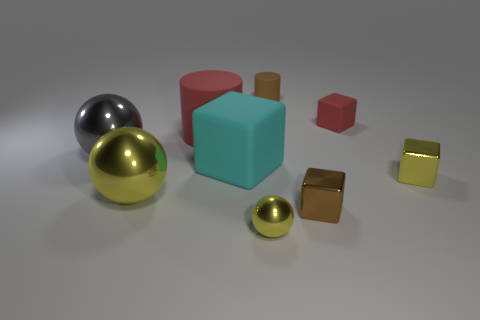The cylinder that is the same color as the small rubber block is what size?
Provide a short and direct response. Large. Is the color of the tiny rubber cube the same as the small cylinder?
Provide a short and direct response. No. What shape is the tiny brown metallic object?
Keep it short and to the point. Cube. Are there any large blocks of the same color as the big cylinder?
Your response must be concise. No. Are there more rubber cylinders on the left side of the large block than small brown rubber cylinders?
Provide a short and direct response. No. Is the shape of the cyan object the same as the red matte object that is left of the small yellow sphere?
Your response must be concise. No. Are any cyan rubber cubes visible?
Make the answer very short. Yes. What number of small things are blue metal cylinders or cyan rubber cubes?
Provide a short and direct response. 0. Is the number of tiny red cubes in front of the big gray shiny thing greater than the number of red matte blocks that are to the left of the tiny metal sphere?
Make the answer very short. No. Is the cyan thing made of the same material as the tiny brown object that is behind the tiny brown shiny block?
Provide a succinct answer. Yes. 